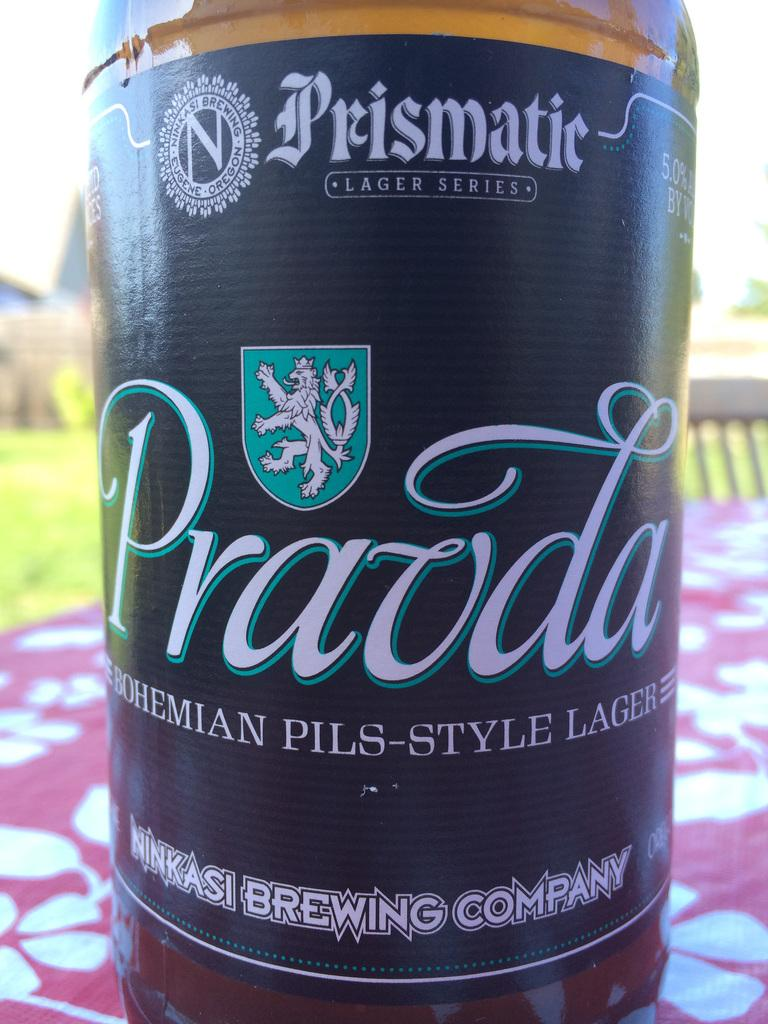<image>
Provide a brief description of the given image. A unit of Ninkasi Brewing Company's Pravda Pils Style Lager. 